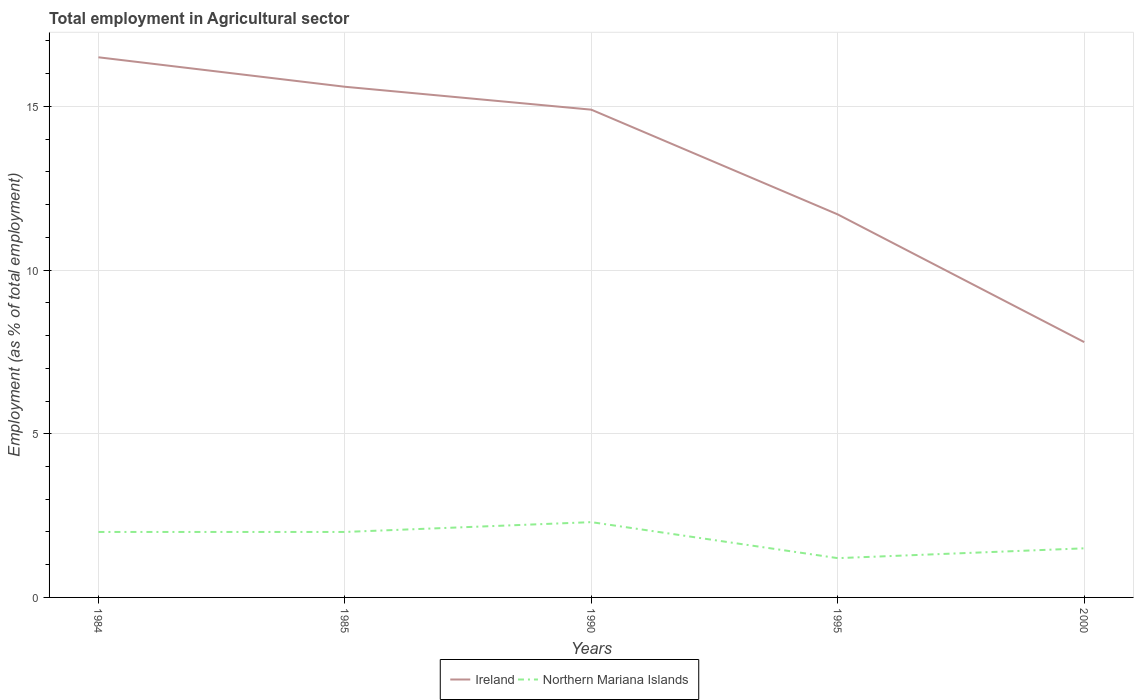How many different coloured lines are there?
Your answer should be compact. 2. Does the line corresponding to Northern Mariana Islands intersect with the line corresponding to Ireland?
Make the answer very short. No. Is the number of lines equal to the number of legend labels?
Your response must be concise. Yes. Across all years, what is the maximum employment in agricultural sector in Ireland?
Your answer should be compact. 7.8. In which year was the employment in agricultural sector in Ireland maximum?
Provide a succinct answer. 2000. What is the total employment in agricultural sector in Northern Mariana Islands in the graph?
Your answer should be compact. 0.5. What is the difference between the highest and the second highest employment in agricultural sector in Northern Mariana Islands?
Your answer should be compact. 1.1. Is the employment in agricultural sector in Ireland strictly greater than the employment in agricultural sector in Northern Mariana Islands over the years?
Give a very brief answer. No. Are the values on the major ticks of Y-axis written in scientific E-notation?
Offer a terse response. No. Does the graph contain any zero values?
Provide a short and direct response. No. Where does the legend appear in the graph?
Your answer should be very brief. Bottom center. How many legend labels are there?
Offer a terse response. 2. What is the title of the graph?
Keep it short and to the point. Total employment in Agricultural sector. Does "Antigua and Barbuda" appear as one of the legend labels in the graph?
Provide a succinct answer. No. What is the label or title of the X-axis?
Keep it short and to the point. Years. What is the label or title of the Y-axis?
Provide a short and direct response. Employment (as % of total employment). What is the Employment (as % of total employment) in Ireland in 1985?
Make the answer very short. 15.6. What is the Employment (as % of total employment) of Ireland in 1990?
Offer a very short reply. 14.9. What is the Employment (as % of total employment) of Northern Mariana Islands in 1990?
Provide a short and direct response. 2.3. What is the Employment (as % of total employment) in Ireland in 1995?
Offer a very short reply. 11.7. What is the Employment (as % of total employment) of Northern Mariana Islands in 1995?
Your answer should be very brief. 1.2. What is the Employment (as % of total employment) of Ireland in 2000?
Offer a very short reply. 7.8. Across all years, what is the maximum Employment (as % of total employment) of Ireland?
Provide a short and direct response. 16.5. Across all years, what is the maximum Employment (as % of total employment) in Northern Mariana Islands?
Offer a terse response. 2.3. Across all years, what is the minimum Employment (as % of total employment) of Ireland?
Provide a short and direct response. 7.8. Across all years, what is the minimum Employment (as % of total employment) of Northern Mariana Islands?
Offer a terse response. 1.2. What is the total Employment (as % of total employment) in Ireland in the graph?
Your response must be concise. 66.5. What is the total Employment (as % of total employment) of Northern Mariana Islands in the graph?
Provide a succinct answer. 9. What is the difference between the Employment (as % of total employment) in Ireland in 1984 and that in 1985?
Your answer should be very brief. 0.9. What is the difference between the Employment (as % of total employment) of Northern Mariana Islands in 1984 and that in 1985?
Provide a succinct answer. 0. What is the difference between the Employment (as % of total employment) in Ireland in 1984 and that in 1990?
Ensure brevity in your answer.  1.6. What is the difference between the Employment (as % of total employment) in Northern Mariana Islands in 1984 and that in 1990?
Keep it short and to the point. -0.3. What is the difference between the Employment (as % of total employment) in Northern Mariana Islands in 1984 and that in 2000?
Offer a terse response. 0.5. What is the difference between the Employment (as % of total employment) of Northern Mariana Islands in 1985 and that in 1990?
Ensure brevity in your answer.  -0.3. What is the difference between the Employment (as % of total employment) of Ireland in 1985 and that in 1995?
Make the answer very short. 3.9. What is the difference between the Employment (as % of total employment) in Northern Mariana Islands in 1985 and that in 1995?
Your answer should be compact. 0.8. What is the difference between the Employment (as % of total employment) in Northern Mariana Islands in 1985 and that in 2000?
Keep it short and to the point. 0.5. What is the difference between the Employment (as % of total employment) of Ireland in 1990 and that in 1995?
Give a very brief answer. 3.2. What is the difference between the Employment (as % of total employment) of Northern Mariana Islands in 1990 and that in 1995?
Give a very brief answer. 1.1. What is the difference between the Employment (as % of total employment) of Northern Mariana Islands in 1990 and that in 2000?
Give a very brief answer. 0.8. What is the difference between the Employment (as % of total employment) in Ireland in 1984 and the Employment (as % of total employment) in Northern Mariana Islands in 1995?
Make the answer very short. 15.3. What is the difference between the Employment (as % of total employment) of Ireland in 1984 and the Employment (as % of total employment) of Northern Mariana Islands in 2000?
Provide a succinct answer. 15. What is the difference between the Employment (as % of total employment) in Ireland in 1985 and the Employment (as % of total employment) in Northern Mariana Islands in 1995?
Your answer should be very brief. 14.4. What is the difference between the Employment (as % of total employment) in Ireland in 1990 and the Employment (as % of total employment) in Northern Mariana Islands in 2000?
Give a very brief answer. 13.4. What is the average Employment (as % of total employment) of Ireland per year?
Provide a short and direct response. 13.3. What is the average Employment (as % of total employment) in Northern Mariana Islands per year?
Your answer should be compact. 1.8. In the year 1985, what is the difference between the Employment (as % of total employment) of Ireland and Employment (as % of total employment) of Northern Mariana Islands?
Your response must be concise. 13.6. In the year 2000, what is the difference between the Employment (as % of total employment) of Ireland and Employment (as % of total employment) of Northern Mariana Islands?
Provide a succinct answer. 6.3. What is the ratio of the Employment (as % of total employment) of Ireland in 1984 to that in 1985?
Your answer should be very brief. 1.06. What is the ratio of the Employment (as % of total employment) of Ireland in 1984 to that in 1990?
Give a very brief answer. 1.11. What is the ratio of the Employment (as % of total employment) of Northern Mariana Islands in 1984 to that in 1990?
Provide a short and direct response. 0.87. What is the ratio of the Employment (as % of total employment) of Ireland in 1984 to that in 1995?
Offer a very short reply. 1.41. What is the ratio of the Employment (as % of total employment) of Ireland in 1984 to that in 2000?
Your response must be concise. 2.12. What is the ratio of the Employment (as % of total employment) of Northern Mariana Islands in 1984 to that in 2000?
Your answer should be compact. 1.33. What is the ratio of the Employment (as % of total employment) in Ireland in 1985 to that in 1990?
Provide a succinct answer. 1.05. What is the ratio of the Employment (as % of total employment) of Northern Mariana Islands in 1985 to that in 1990?
Ensure brevity in your answer.  0.87. What is the ratio of the Employment (as % of total employment) in Ireland in 1985 to that in 1995?
Offer a very short reply. 1.33. What is the ratio of the Employment (as % of total employment) in Northern Mariana Islands in 1985 to that in 1995?
Give a very brief answer. 1.67. What is the ratio of the Employment (as % of total employment) in Ireland in 1985 to that in 2000?
Your answer should be very brief. 2. What is the ratio of the Employment (as % of total employment) of Northern Mariana Islands in 1985 to that in 2000?
Offer a very short reply. 1.33. What is the ratio of the Employment (as % of total employment) of Ireland in 1990 to that in 1995?
Make the answer very short. 1.27. What is the ratio of the Employment (as % of total employment) in Northern Mariana Islands in 1990 to that in 1995?
Keep it short and to the point. 1.92. What is the ratio of the Employment (as % of total employment) in Ireland in 1990 to that in 2000?
Ensure brevity in your answer.  1.91. What is the ratio of the Employment (as % of total employment) of Northern Mariana Islands in 1990 to that in 2000?
Your answer should be compact. 1.53. What is the ratio of the Employment (as % of total employment) in Ireland in 1995 to that in 2000?
Offer a very short reply. 1.5. What is the difference between the highest and the lowest Employment (as % of total employment) of Ireland?
Offer a terse response. 8.7. What is the difference between the highest and the lowest Employment (as % of total employment) of Northern Mariana Islands?
Ensure brevity in your answer.  1.1. 